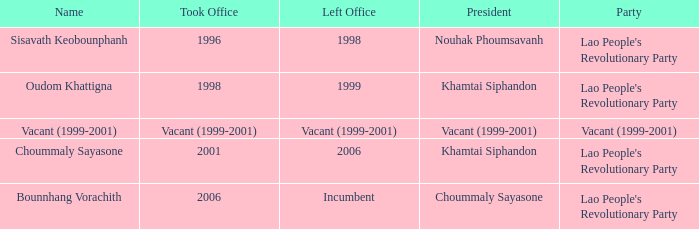In the period of 1999-2001, when did the left office happen if the party was vacant? Vacant (1999-2001). 